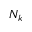Convert formula to latex. <formula><loc_0><loc_0><loc_500><loc_500>N _ { k }</formula> 